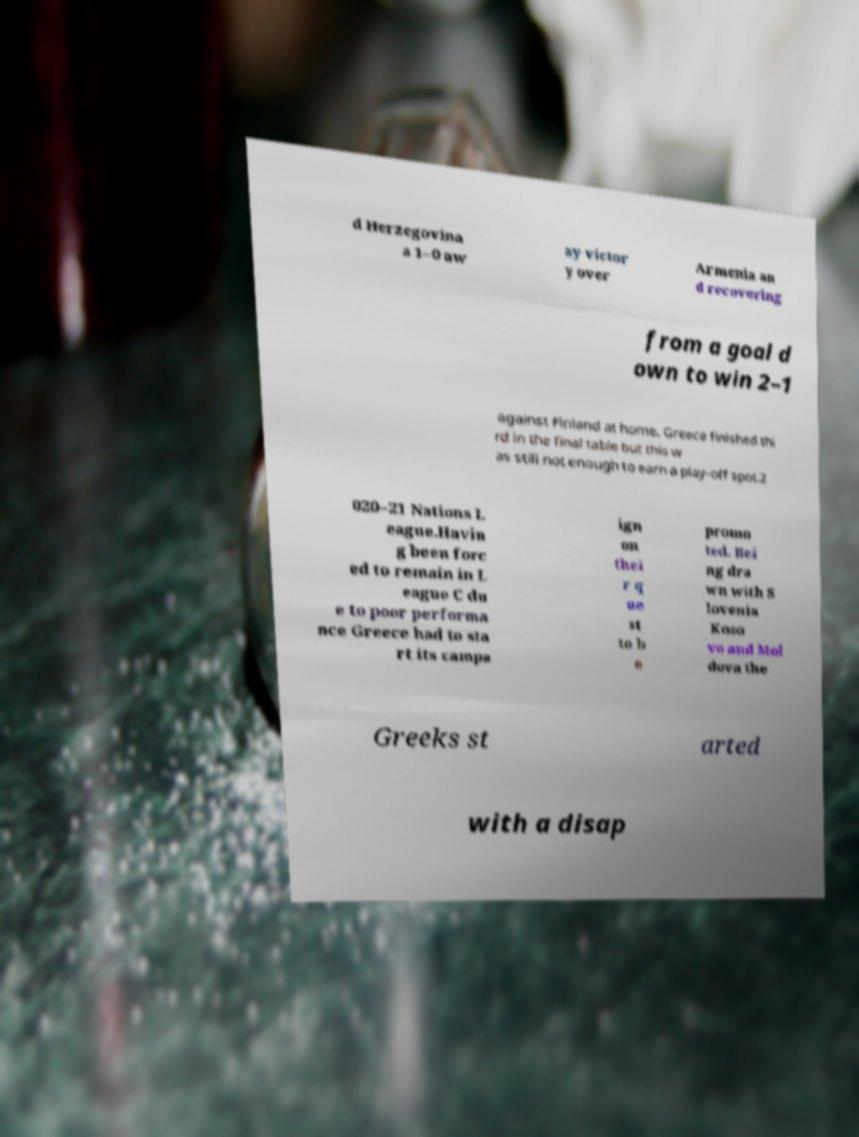Could you extract and type out the text from this image? d Herzegovina a 1–0 aw ay victor y over Armenia an d recovering from a goal d own to win 2–1 against Finland at home. Greece finished thi rd in the final table but this w as still not enough to earn a play-off spot.2 020–21 Nations L eague.Havin g been forc ed to remain in L eague C du e to poor performa nce Greece had to sta rt its campa ign on thei r q ue st to b e promo ted. Bei ng dra wn with S lovenia Koso vo and Mol dova the Greeks st arted with a disap 